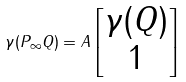Convert formula to latex. <formula><loc_0><loc_0><loc_500><loc_500>\gamma ( P _ { \infty } Q ) = A \begin{bmatrix} \gamma ( Q ) \\ 1 \end{bmatrix}</formula> 